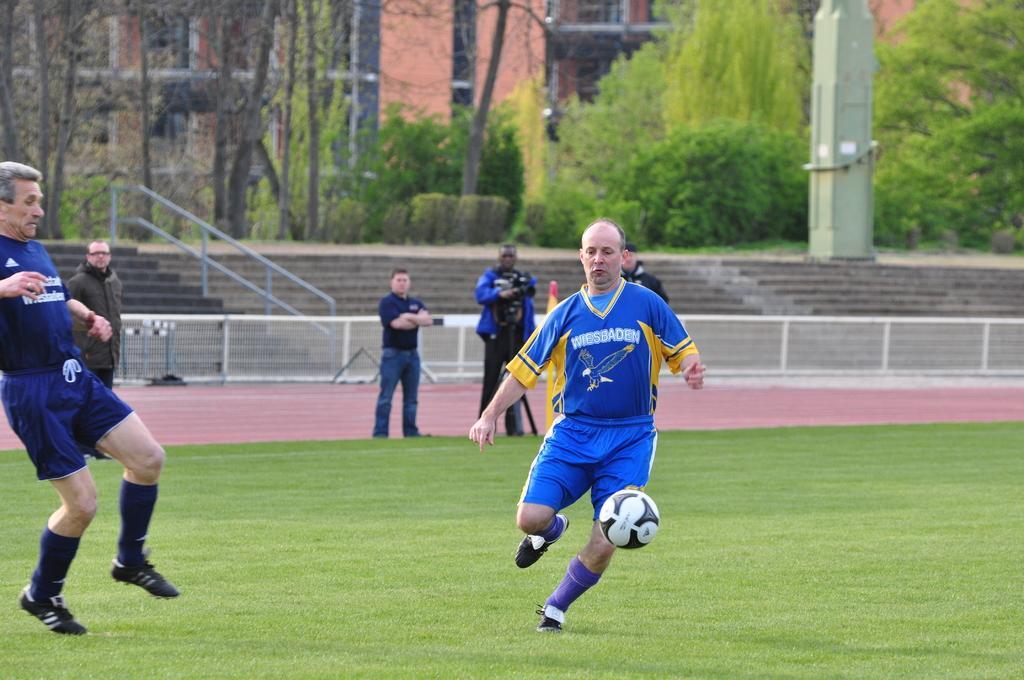How would you summarize this image in a sentence or two? In this image we can see two people are playing football and other persons are watching them. On the top of the image we can see building, trees and steps. 